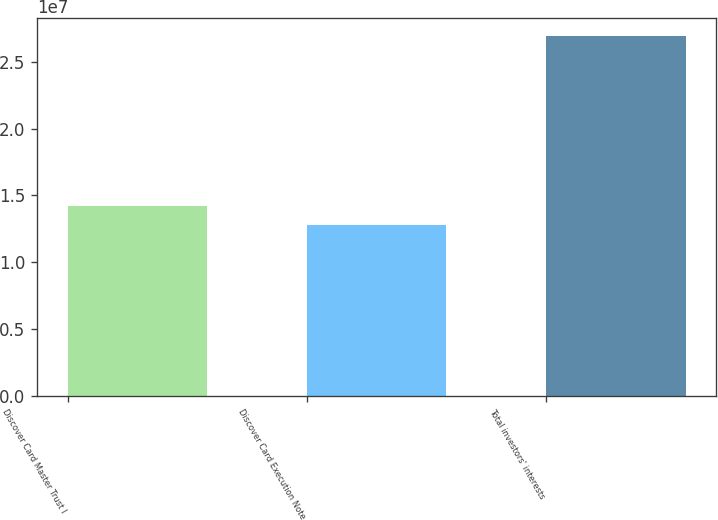<chart> <loc_0><loc_0><loc_500><loc_500><bar_chart><fcel>Discover Card Master Trust I<fcel>Discover Card Execution Note<fcel>Total investors' interests<nl><fcel>1.41728e+07<fcel>1.27594e+07<fcel>2.68936e+07<nl></chart> 